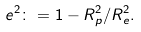Convert formula to latex. <formula><loc_0><loc_0><loc_500><loc_500>e ^ { 2 } \colon = 1 - R _ { p } ^ { 2 } / R _ { e } ^ { 2 } .</formula> 